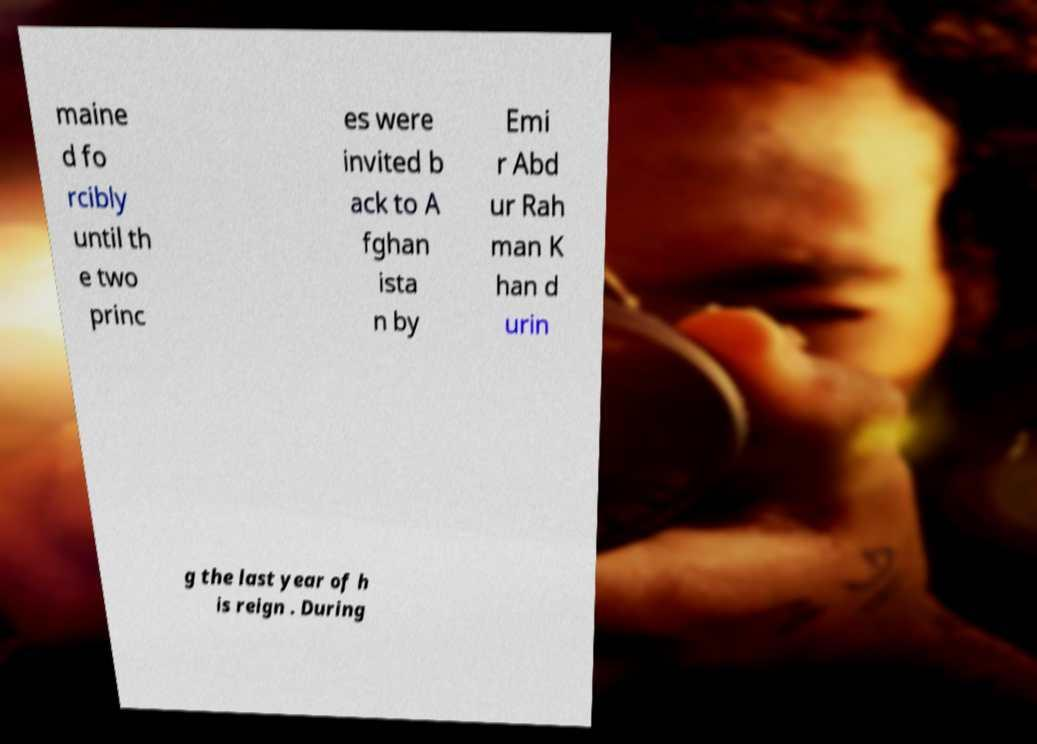Please identify and transcribe the text found in this image. maine d fo rcibly until th e two princ es were invited b ack to A fghan ista n by Emi r Abd ur Rah man K han d urin g the last year of h is reign . During 